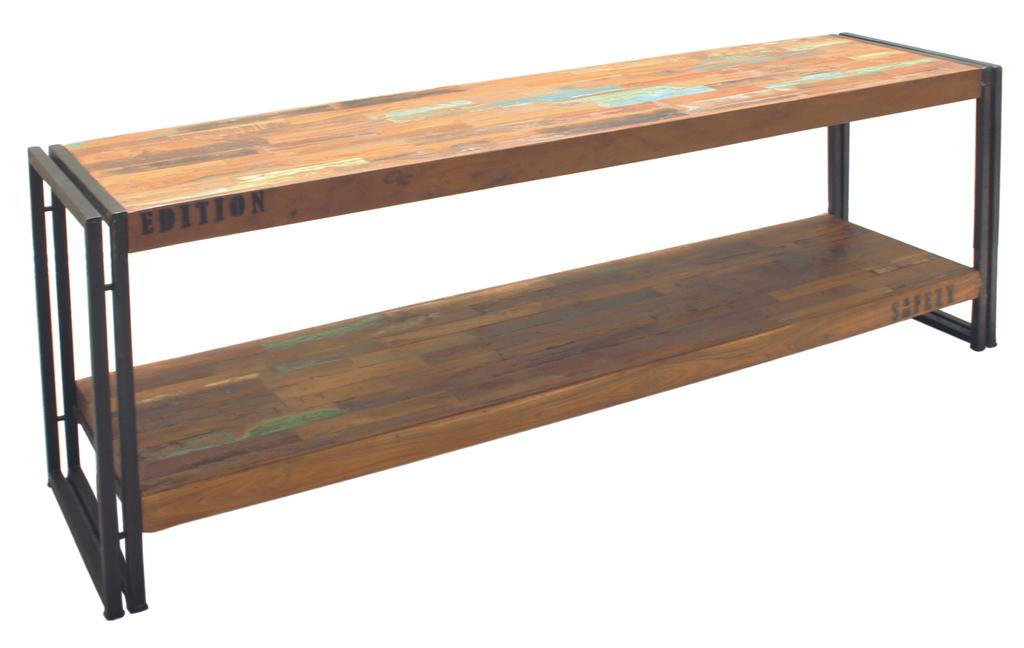Provide a one-sentence caption for the provided image. A wooden shelving unit has the word Edition stenciled onto the side. 